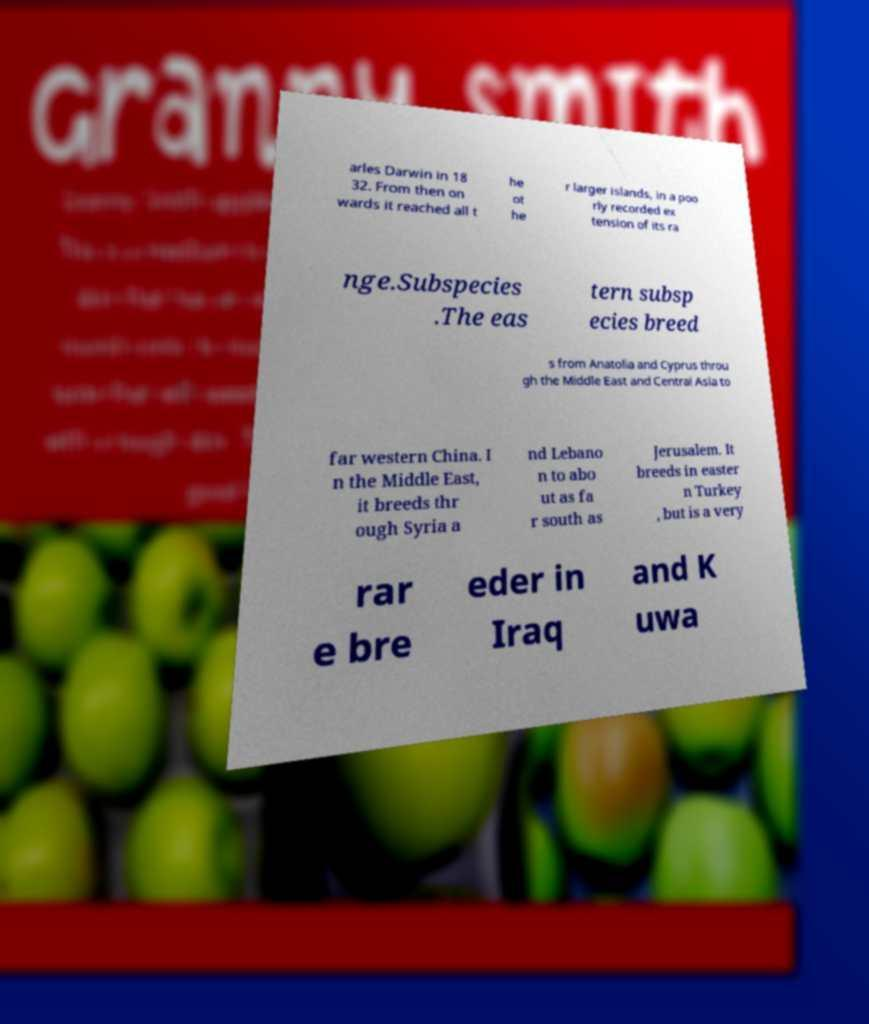What messages or text are displayed in this image? I need them in a readable, typed format. arles Darwin in 18 32. From then on wards it reached all t he ot he r larger islands, in a poo rly recorded ex tension of its ra nge.Subspecies .The eas tern subsp ecies breed s from Anatolia and Cyprus throu gh the Middle East and Central Asia to far western China. I n the Middle East, it breeds thr ough Syria a nd Lebano n to abo ut as fa r south as Jerusalem. It breeds in easter n Turkey , but is a very rar e bre eder in Iraq and K uwa 